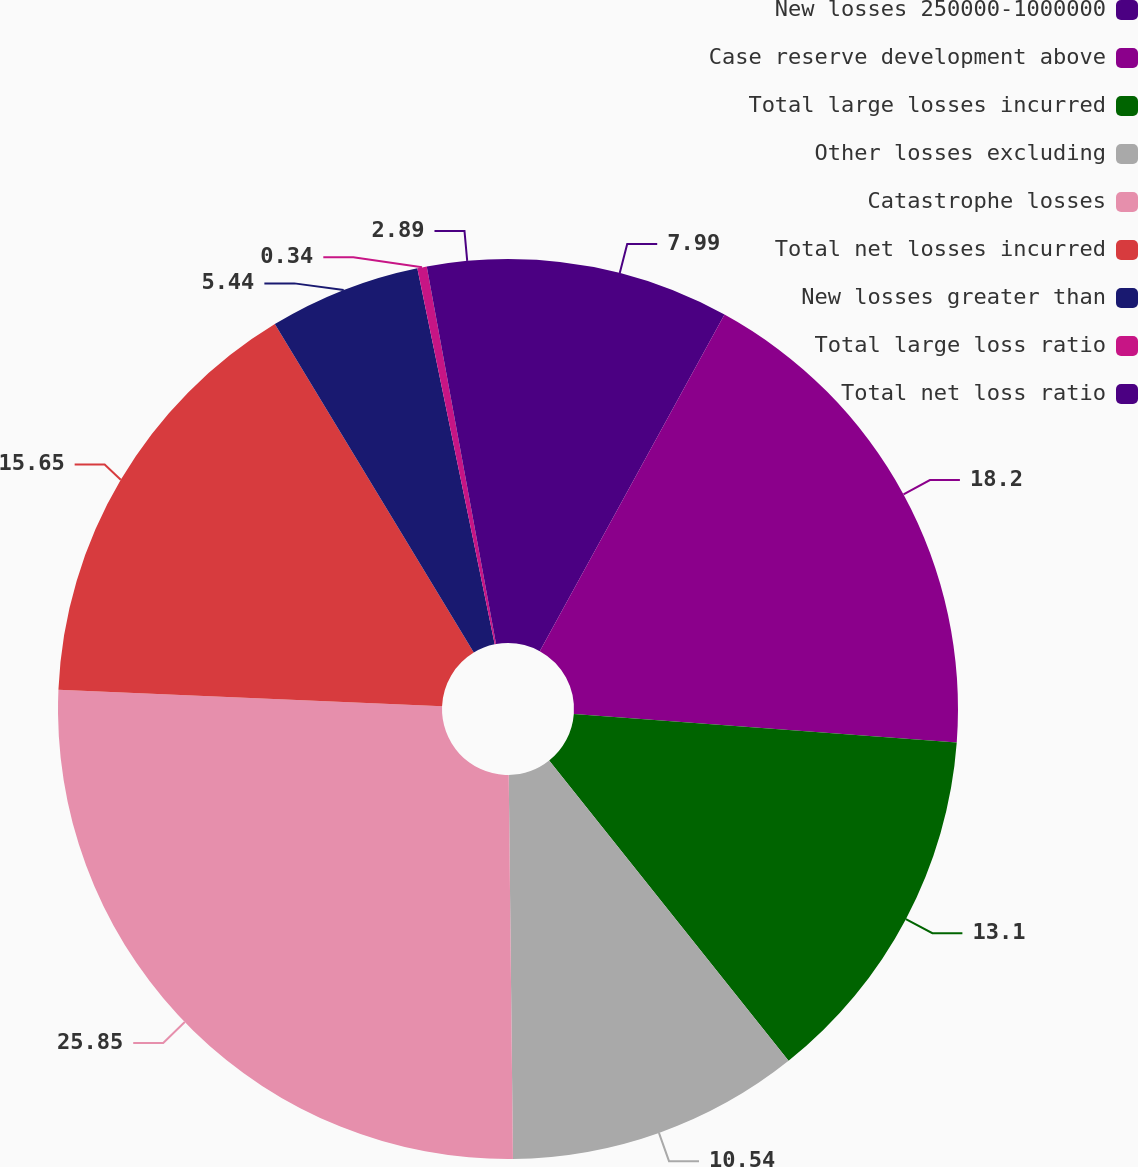Convert chart to OTSL. <chart><loc_0><loc_0><loc_500><loc_500><pie_chart><fcel>New losses 250000-1000000<fcel>Case reserve development above<fcel>Total large losses incurred<fcel>Other losses excluding<fcel>Catastrophe losses<fcel>Total net losses incurred<fcel>New losses greater than<fcel>Total large loss ratio<fcel>Total net loss ratio<nl><fcel>7.99%<fcel>18.2%<fcel>13.1%<fcel>10.54%<fcel>25.86%<fcel>15.65%<fcel>5.44%<fcel>0.34%<fcel>2.89%<nl></chart> 